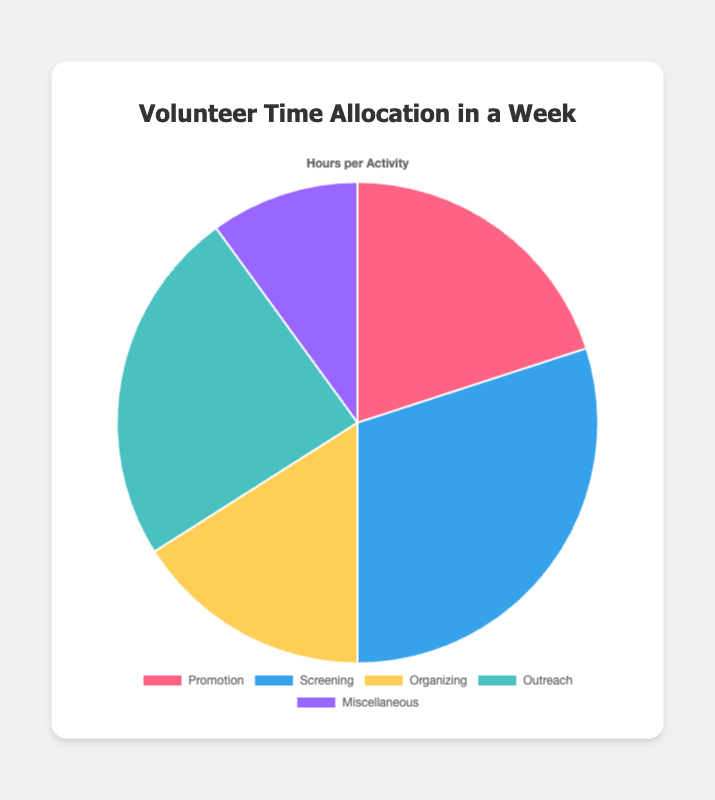What percentage of the total time is spent on Promotion and Outreach combined? First, identify the hours spent on Promotion (10) and Outreach (12). Add them together: 10 + 12 = 22. Sum all categories: 10 + 15 + 8 + 12 + 5 = 50. Divide the combined hours by the total hours and multiply by 100: (22/50) * 100 = 44%
Answer: 44% How many hours are allocated to activities other than Screening? Identify the hours spent on each category other than Screening: Promotion (10), Organizing (8), Outreach (12), Miscellaneous (5). Add them together: 10 + 8 + 12 + 5 = 35
Answer: 35 What is the difference in hours between Screening and Miscellaneous activities? Identify the hours spent on Screening (15) and Miscellaneous (5). Subtract the Miscellaneous hours from the Screening hours: 15 - 5 = 10
Answer: 10 Which activity takes up the smallest portion of the pie chart? Look at the category with the fewest hours. Miscellaneous has the smallest number of hours: 5
Answer: Miscellaneous Is more time spent on Outreach or Organizing activities? Identify the hours spent on Outreach (12) and Organizing (8) and compare them. Outreach has more hours: 12 > 8
Answer: Outreach What proportion of the total time is spent on Screening? Identify the hours spent on Screening: 15. Sum all categories: 10 + 15 + 8 + 12 + 5 = 50. Divide the Screening hours by the total hours and multiply by 100: (15/50) * 100 = 30%
Answer: 30% What is the average time spent on all activities? Sum all the hours: 10 + 15 + 8 + 12 + 5 = 50. Divide by the number of activities: 50/5 = 10 hours
Answer: 10 Which color represents the Promotion activity in the pie chart? Promotion is represented by the first color in the legend and pie slices, which is red.
Answer: Red Between Outreach and Promotion, which activity uses more time and by how much? Identify the hours spent on Outreach (12) and Promotion (10). Subtract Promotion from Outreach: 12 - 10 = 2
Answer: Outreach, by 2 hours 